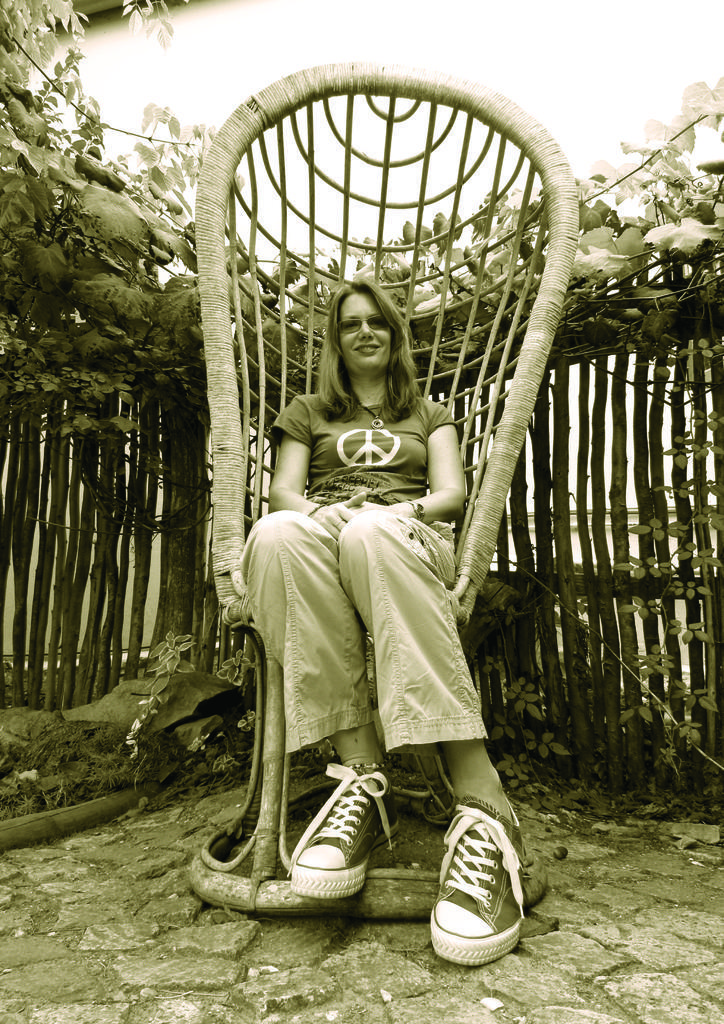In one or two sentences, can you explain what this image depicts? In this picture there is a girl who is sitting on a chair and there are trees around the area of the image and the girl is wearing sun glasses and shoes. 